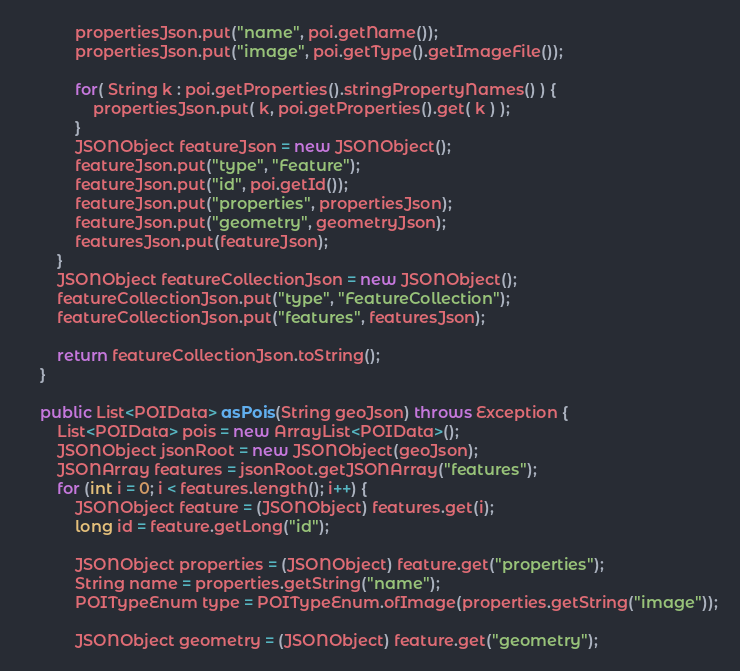Convert code to text. <code><loc_0><loc_0><loc_500><loc_500><_Java_>            propertiesJson.put("name", poi.getName());
            propertiesJson.put("image", poi.getType().getImageFile());

            for( String k : poi.getProperties().stringPropertyNames() ) {
                propertiesJson.put( k, poi.getProperties().get( k ) );
            }
            JSONObject featureJson = new JSONObject();
            featureJson.put("type", "Feature");
            featureJson.put("id", poi.getId());
            featureJson.put("properties", propertiesJson);
            featureJson.put("geometry", geometryJson);
            featuresJson.put(featureJson);
        }
        JSONObject featureCollectionJson = new JSONObject();
        featureCollectionJson.put("type", "FeatureCollection");
        featureCollectionJson.put("features", featuresJson);

        return featureCollectionJson.toString();
    }

    public List<POIData> asPois(String geoJson) throws Exception {
        List<POIData> pois = new ArrayList<POIData>();
        JSONObject jsonRoot = new JSONObject(geoJson);
        JSONArray features = jsonRoot.getJSONArray("features");
        for (int i = 0; i < features.length(); i++) {
            JSONObject feature = (JSONObject) features.get(i);
            long id = feature.getLong("id");

            JSONObject properties = (JSONObject) feature.get("properties");
            String name = properties.getString("name");
            POITypeEnum type = POITypeEnum.ofImage(properties.getString("image"));

            JSONObject geometry = (JSONObject) feature.get("geometry");</code> 